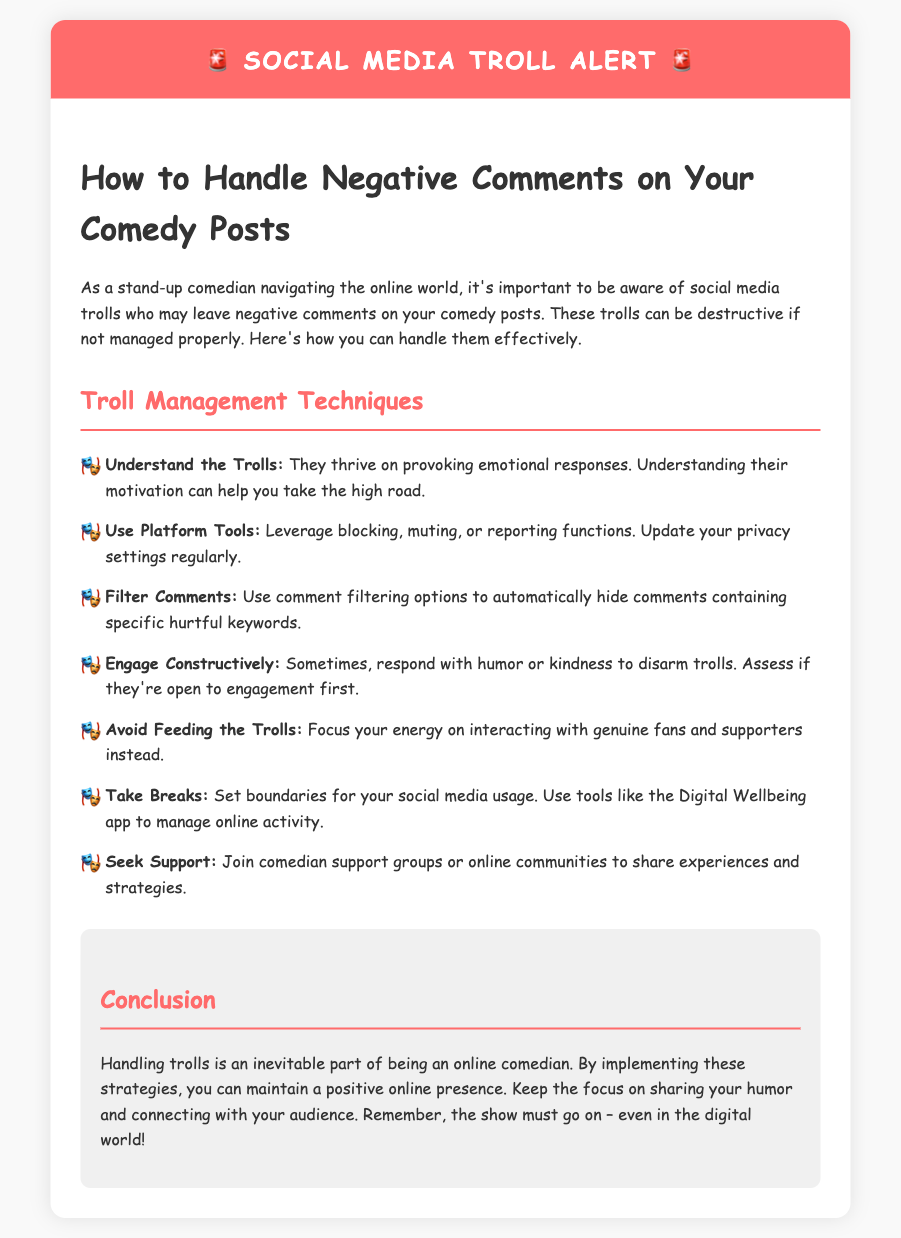what is the title of the document? The title is displayed prominently as the main heading in the document.
Answer: How to Handle Negative Comments on Your Comedy Posts what color is the warning header? The color of the warning header is mentioned in the styling of the document.
Answer: #ff6b6b how many troll management techniques are listed? The list items in the document count the number of techniques presented.
Answer: seven what should you do to engage with trolls constructively? This is found in one of the listed techniques in the document.
Answer: respond with humor or kindness which app can help manage your online activity? The document mentions a specific app for this purpose.
Answer: Digital Wellbeing app what is the main goal when handling trolls? The document aims to communicate the overall purpose of dealing with negative comments.
Answer: maintain a positive online presence what is the main advice given for avoiding engagement with trolls? The advice is a straightforward tactic from the document.
Answer: Avoid Feeding the Trolls what type of support can comedians seek according to the document? The document suggests a specific type of group or community for comedians.
Answer: comedian support groups 